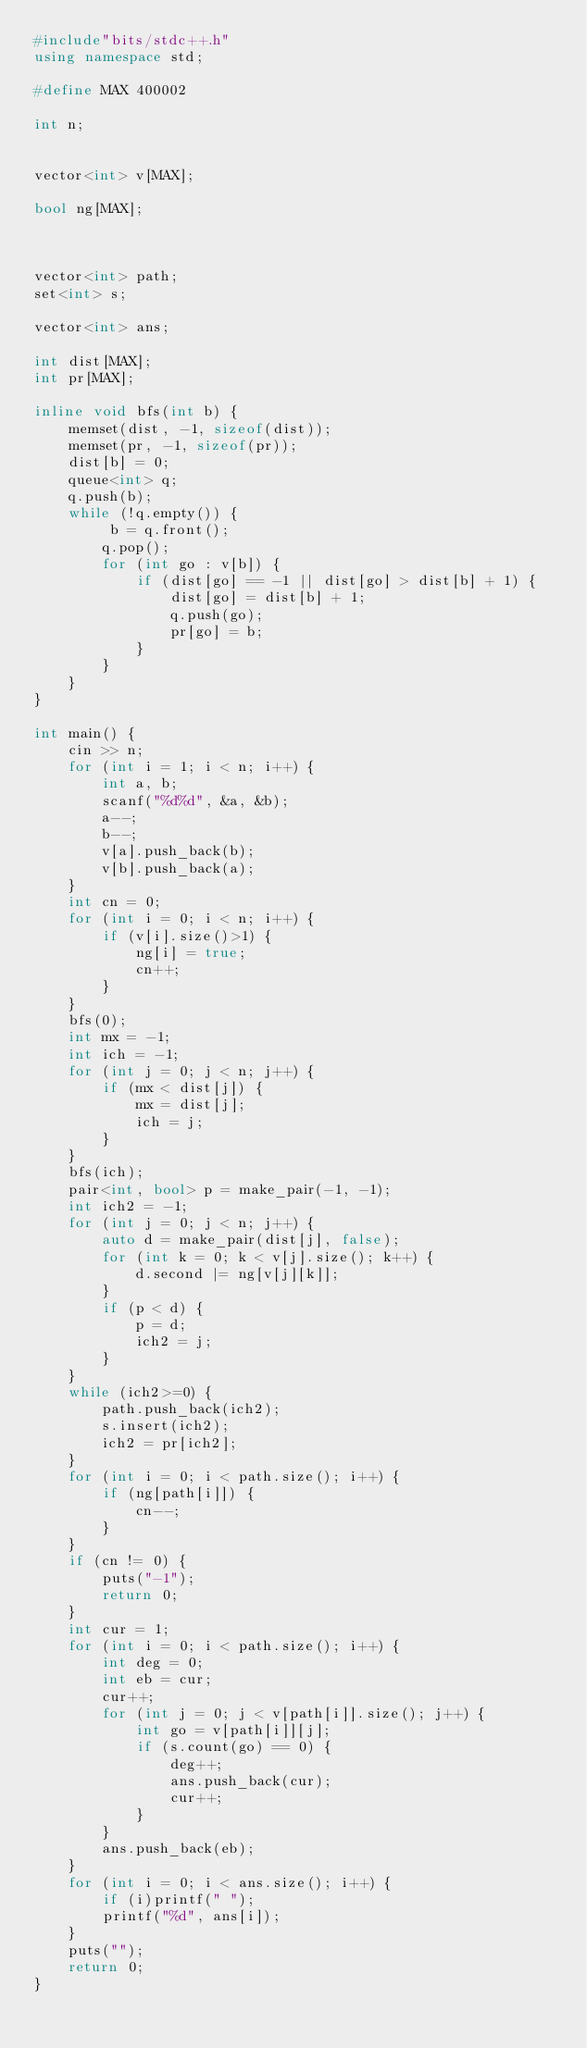Convert code to text. <code><loc_0><loc_0><loc_500><loc_500><_C++_>#include"bits/stdc++.h"
using namespace std;

#define MAX 400002

int n;


vector<int> v[MAX];

bool ng[MAX];



vector<int> path;
set<int> s;

vector<int> ans;

int dist[MAX];
int pr[MAX];

inline void bfs(int b) {
	memset(dist, -1, sizeof(dist));
	memset(pr, -1, sizeof(pr));
	dist[b] = 0;
	queue<int> q;
	q.push(b);
	while (!q.empty()) {
		 b = q.front();
		q.pop();
		for (int go : v[b]) {
			if (dist[go] == -1 || dist[go] > dist[b] + 1) {
				dist[go] = dist[b] + 1;
				q.push(go);
				pr[go] = b;
			}
		}
	}
}

int main() {
	cin >> n;
	for (int i = 1; i < n; i++) {
		int a, b;
		scanf("%d%d", &a, &b);
		a--;
		b--;
		v[a].push_back(b);
		v[b].push_back(a);
	}
	int cn = 0;
	for (int i = 0; i < n; i++) {
		if (v[i].size()>1) {
			ng[i] = true;
			cn++;
		}
	}
	bfs(0);
	int mx = -1;
	int ich = -1;
	for (int j = 0; j < n; j++) {
		if (mx < dist[j]) {
			mx = dist[j];
			ich = j;
		}
	}
	bfs(ich);
	pair<int, bool> p = make_pair(-1, -1);
	int ich2 = -1;
	for (int j = 0; j < n; j++) {
		auto d = make_pair(dist[j], false);
		for (int k = 0; k < v[j].size(); k++) {
			d.second |= ng[v[j][k]];
		}
		if (p < d) {
			p = d;
			ich2 = j;
		}
	}
	while (ich2>=0) {
		path.push_back(ich2);
		s.insert(ich2);
		ich2 = pr[ich2];
	}
	for (int i = 0; i < path.size(); i++) {
		if (ng[path[i]]) {
			cn--;
		}
	}
	if (cn != 0) {
		puts("-1");
		return 0;
	}
	int cur = 1;
	for (int i = 0; i < path.size(); i++) {
		int deg = 0;
		int eb = cur;
		cur++;
		for (int j = 0; j < v[path[i]].size(); j++) {
			int go = v[path[i]][j];
			if (s.count(go) == 0) {
				deg++;
				ans.push_back(cur);
				cur++;
			}
		}
		ans.push_back(eb);
	}
	for (int i = 0; i < ans.size(); i++) {
		if (i)printf(" ");
		printf("%d", ans[i]);
	}
	puts("");
	return 0;
}</code> 